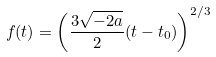Convert formula to latex. <formula><loc_0><loc_0><loc_500><loc_500>f ( t ) = \left ( \frac { 3 \sqrt { - 2 a } } { 2 } ( t - t _ { 0 } ) \right ) ^ { 2 / 3 }</formula> 